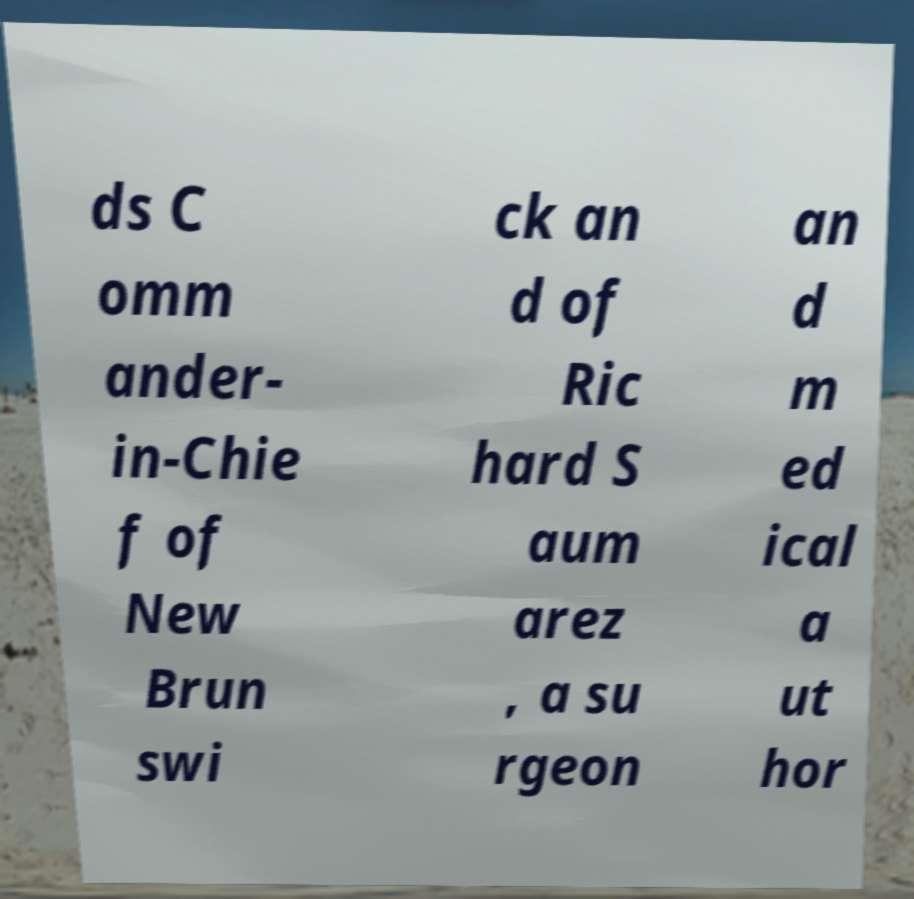Please read and relay the text visible in this image. What does it say? ds C omm ander- in-Chie f of New Brun swi ck an d of Ric hard S aum arez , a su rgeon an d m ed ical a ut hor 